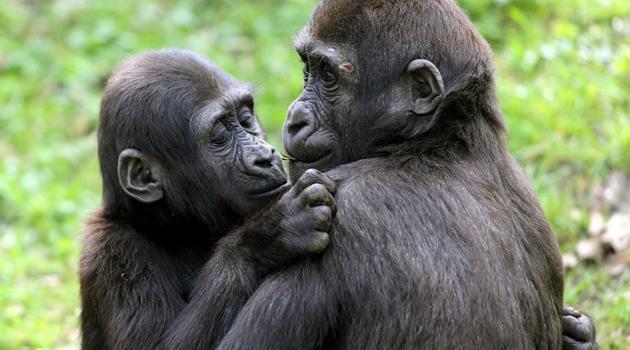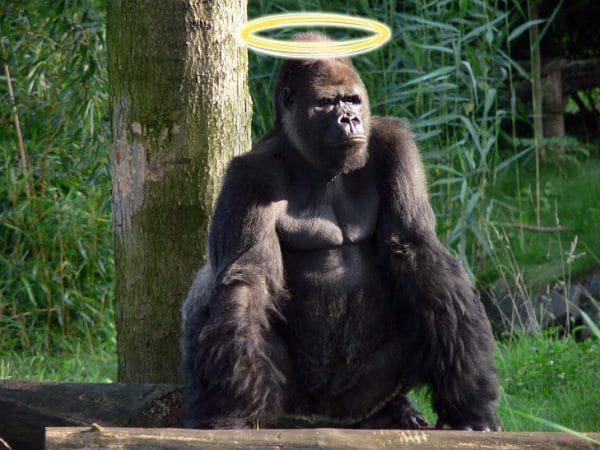The first image is the image on the left, the second image is the image on the right. Considering the images on both sides, is "There are more animals in the image on the right." valid? Answer yes or no. No. The first image is the image on the left, the second image is the image on the right. Assess this claim about the two images: "The right image contains one gorilla, an adult male with its arms extended down to the ground in front of its body.". Correct or not? Answer yes or no. Yes. 